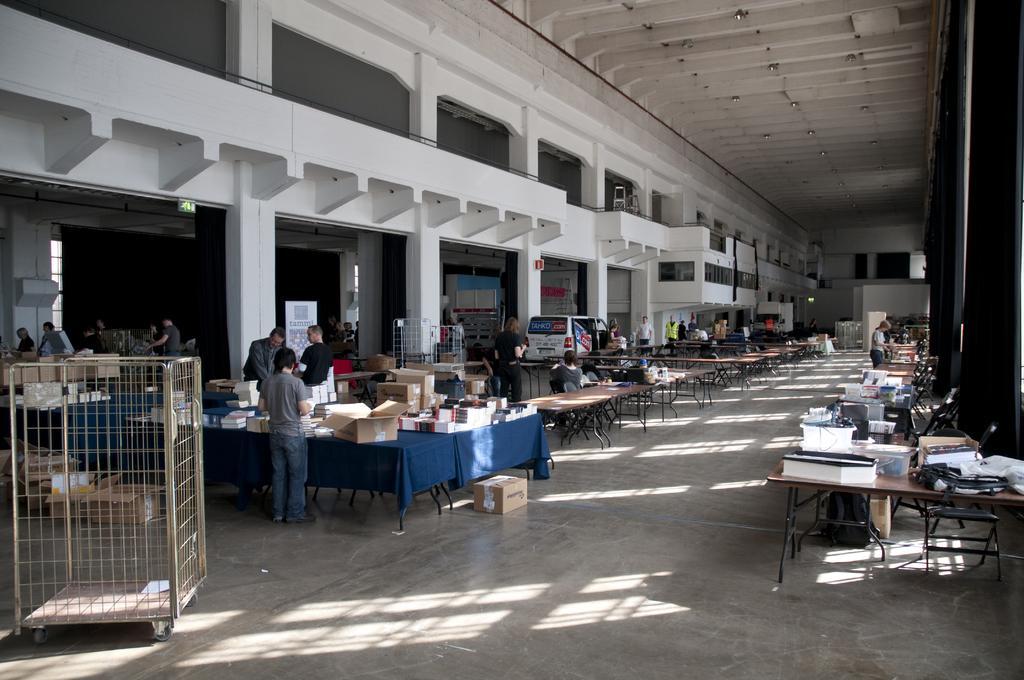In one or two sentences, can you explain what this image depicts? This is the place where we have some tables and chairs to the left side and on the right side there are some discount which there are some things are placed and also there is a car and some people in the room. 